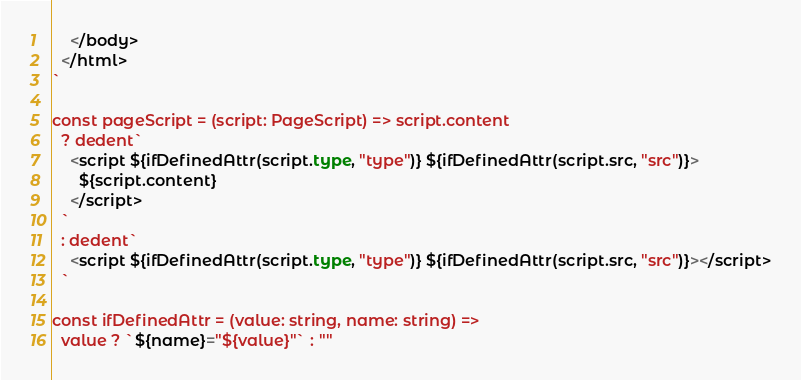Convert code to text. <code><loc_0><loc_0><loc_500><loc_500><_TypeScript_>    </body>
  </html>
`

const pageScript = (script: PageScript) => script.content
  ? dedent`
    <script ${ifDefinedAttr(script.type, "type")} ${ifDefinedAttr(script.src, "src")}>
      ${script.content} 
    </script>
  `
  : dedent`
    <script ${ifDefinedAttr(script.type, "type")} ${ifDefinedAttr(script.src, "src")}></script>
  `

const ifDefinedAttr = (value: string, name: string) =>
  value ? `${name}="${value}"` : ""
</code> 